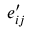<formula> <loc_0><loc_0><loc_500><loc_500>e _ { i j } ^ { \prime }</formula> 